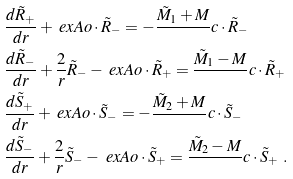Convert formula to latex. <formula><loc_0><loc_0><loc_500><loc_500>& \frac { d \tilde { R } _ { + } } { d r } + \ e x A o \cdot \tilde { R } _ { - } = - \frac { \tilde { M } _ { 1 } + M } { } c \cdot \tilde { R } _ { - } \\ & \frac { d \tilde { R } _ { - } } { d r } + \frac { 2 } { r } \tilde { R } _ { - } - \ e x A o \cdot \tilde { R } _ { + } = \frac { \tilde { M } _ { 1 } - M } { } c \cdot \tilde { R } _ { + } \\ & \frac { d \tilde { S } _ { + } } { d r } + \ e x A o \cdot \tilde { S } _ { - } = - \frac { \tilde { M } _ { 2 } + M } { } c \cdot \tilde { S } _ { - } \\ & \frac { d \tilde { S } _ { - } } { d r } + \frac { 2 } { r } \tilde { S } _ { - } - \ e x A o \cdot \tilde { S } _ { + } = \frac { \tilde { M } _ { 2 } - M } { } c \cdot \tilde { S } _ { + } \ .</formula> 